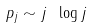<formula> <loc_0><loc_0><loc_500><loc_500>p _ { j } \sim j \ \log j</formula> 